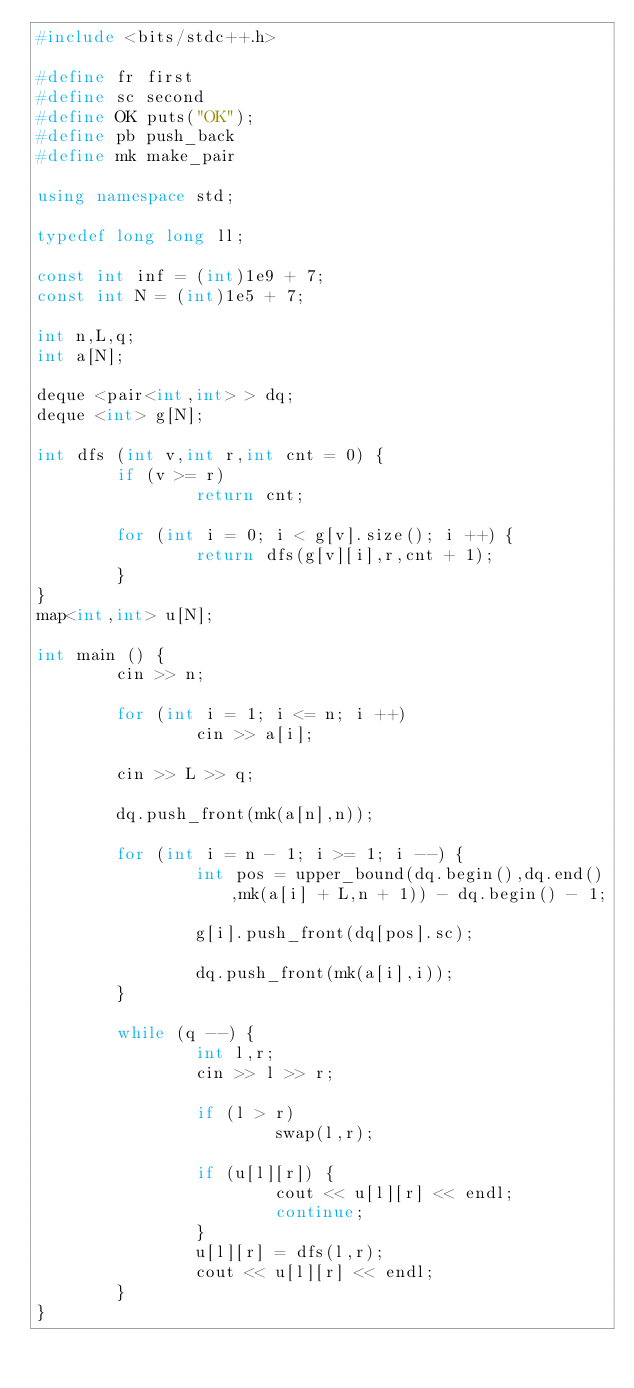Convert code to text. <code><loc_0><loc_0><loc_500><loc_500><_C++_>#include <bits/stdc++.h>

#define fr first
#define sc second
#define OK puts("OK");
#define pb push_back
#define mk make_pair

using namespace std;

typedef long long ll;

const int inf = (int)1e9 + 7;
const int N = (int)1e5 + 7;

int n,L,q;
int a[N];

deque <pair<int,int> > dq;
deque <int> g[N];

int dfs (int v,int r,int cnt = 0) {
        if (v >= r)
                return cnt;

        for (int i = 0; i < g[v].size(); i ++) {
                return dfs(g[v][i],r,cnt + 1);
        }
}
map<int,int> u[N];

int main () {
        cin >> n;

        for (int i = 1; i <= n; i ++)
                cin >> a[i];

        cin >> L >> q;

        dq.push_front(mk(a[n],n));

        for (int i = n - 1; i >= 1; i --) {
                int pos = upper_bound(dq.begin(),dq.end(),mk(a[i] + L,n + 1)) - dq.begin() - 1;

                g[i].push_front(dq[pos].sc);

                dq.push_front(mk(a[i],i));
        }

        while (q --) {
                int l,r;
                cin >> l >> r;

                if (l > r)
                        swap(l,r);

                if (u[l][r]) {
                        cout << u[l][r] << endl;
                        continue;
                }
                u[l][r] = dfs(l,r);
                cout << u[l][r] << endl;
        }
}
</code> 